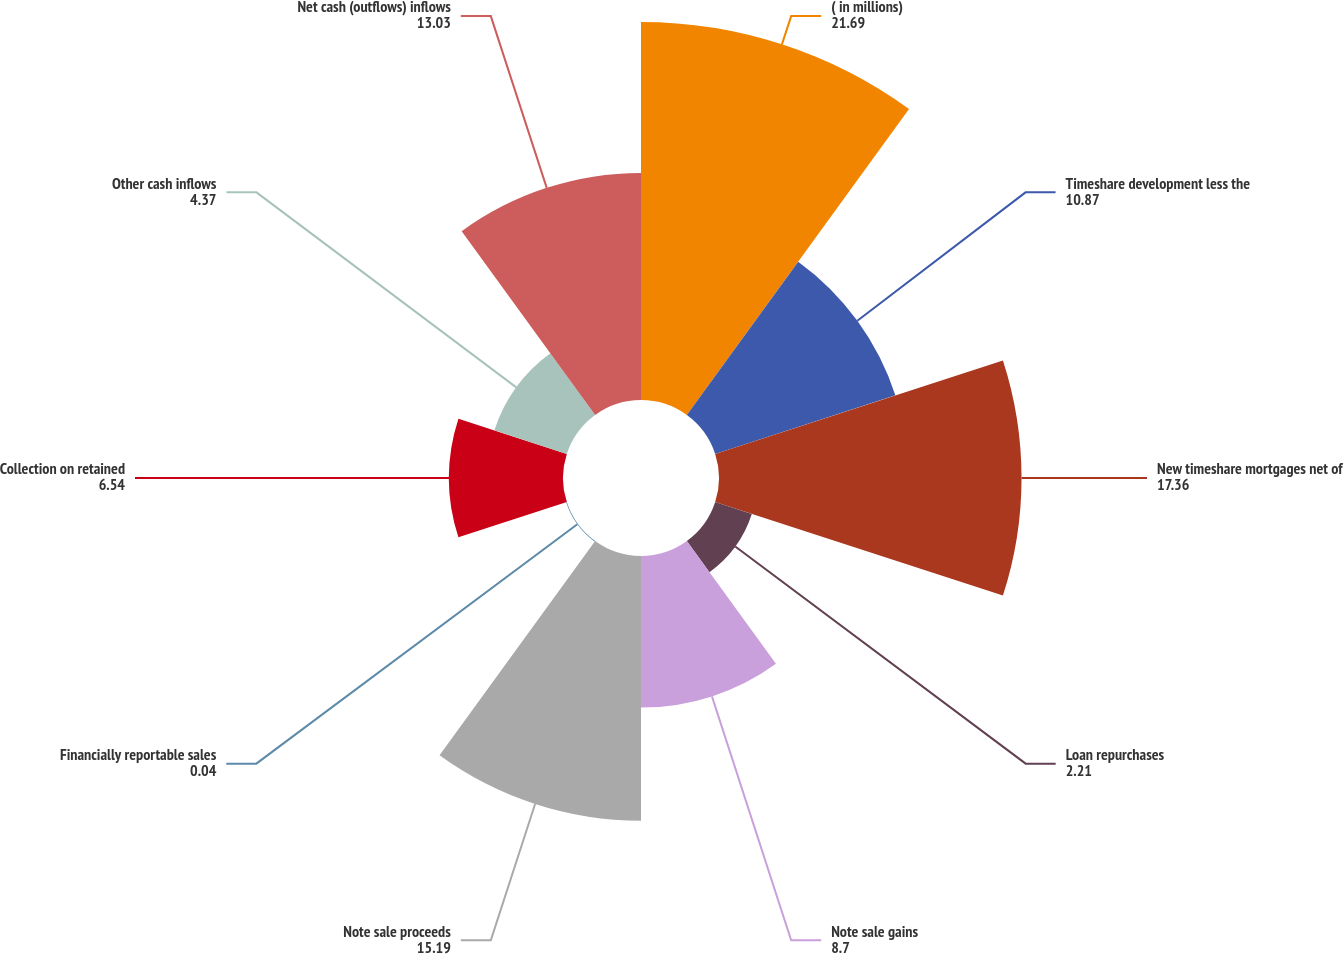Convert chart to OTSL. <chart><loc_0><loc_0><loc_500><loc_500><pie_chart><fcel>( in millions)<fcel>Timeshare development less the<fcel>New timeshare mortgages net of<fcel>Loan repurchases<fcel>Note sale gains<fcel>Note sale proceeds<fcel>Financially reportable sales<fcel>Collection on retained<fcel>Other cash inflows<fcel>Net cash (outflows) inflows<nl><fcel>21.69%<fcel>10.87%<fcel>17.36%<fcel>2.21%<fcel>8.7%<fcel>15.19%<fcel>0.04%<fcel>6.54%<fcel>4.37%<fcel>13.03%<nl></chart> 